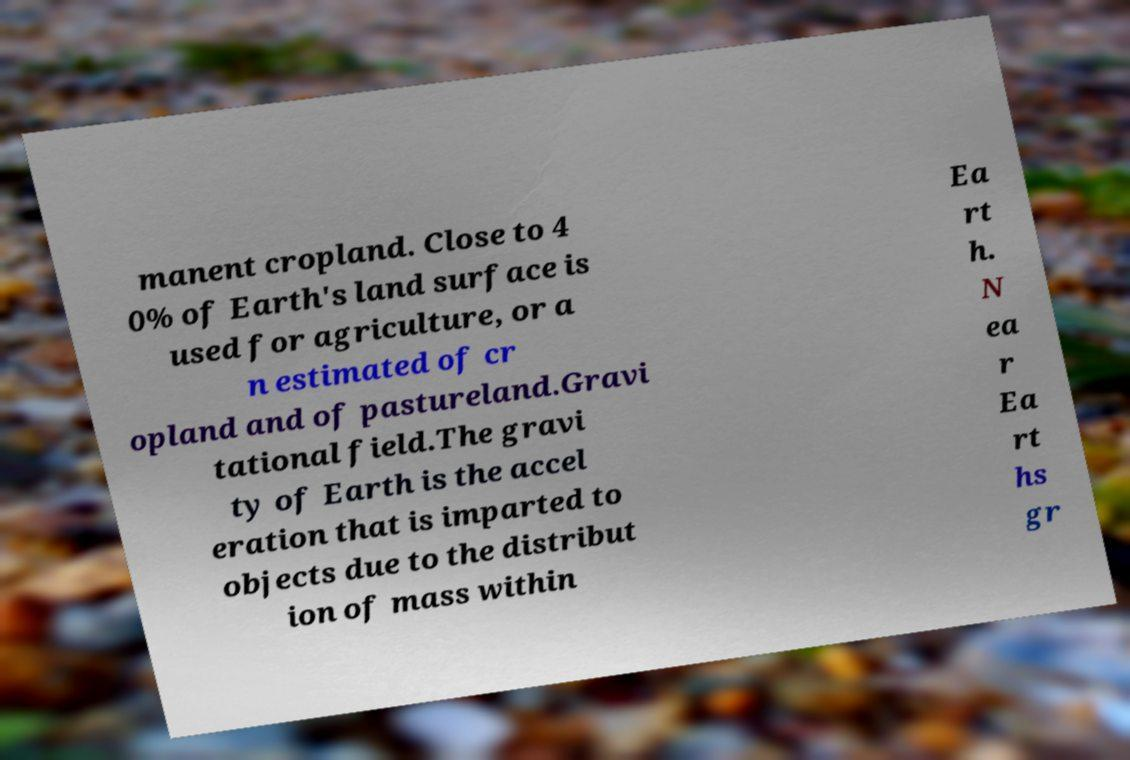Please identify and transcribe the text found in this image. manent cropland. Close to 4 0% of Earth's land surface is used for agriculture, or a n estimated of cr opland and of pastureland.Gravi tational field.The gravi ty of Earth is the accel eration that is imparted to objects due to the distribut ion of mass within Ea rt h. N ea r Ea rt hs gr 